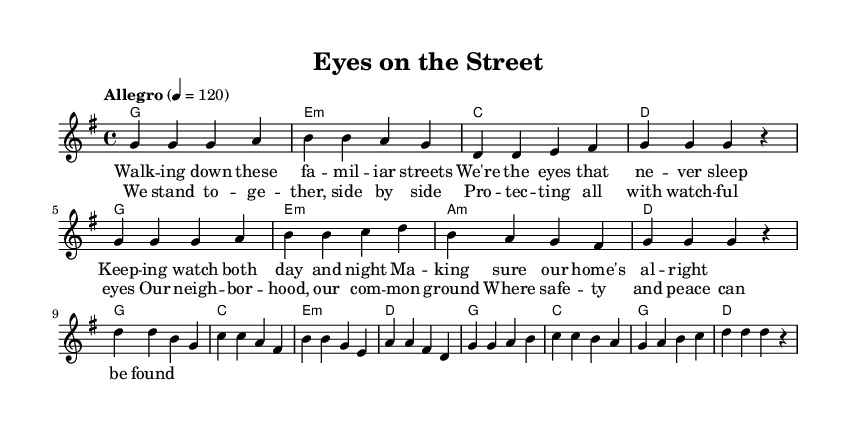What is the key signature of this music? The key signature is G major, which has one sharp on the F line. This can be seen in the global settings of the sheet music.
Answer: G major What is the time signature of this music? The time signature is 4/4, indicating four beats in each measure and a quarter note gets one beat. This is noted in the global settings at the beginning of the music.
Answer: 4/4 What is the tempo marking of this piece? The tempo marking is "Allegro" with a tempo of 120 beats per minute, which indicates a fast and lively pace. This information is provided in the global settings.
Answer: Allegro 120 How many measures are in the verse section? The verse section contains eight measures, which can be counted from the melody part where the repeats and phrasing are clearly laid out.
Answer: Eight How does the harmony change in the chorus compared to the verse? The harmony in the chorus features a shift from G major to C major, showcasing a more uplifting progression. The chords in the chorus are listed under the harmonies and differ from those in the verse.
Answer: G major to C major What is the main theme of the lyrics? The main theme of the lyrics is community solidarity and neighborhood safety, focusing on the idea of people coming together to protect one another. This can be derived from the verses that emphasize watching over the community.
Answer: Community solidarity 